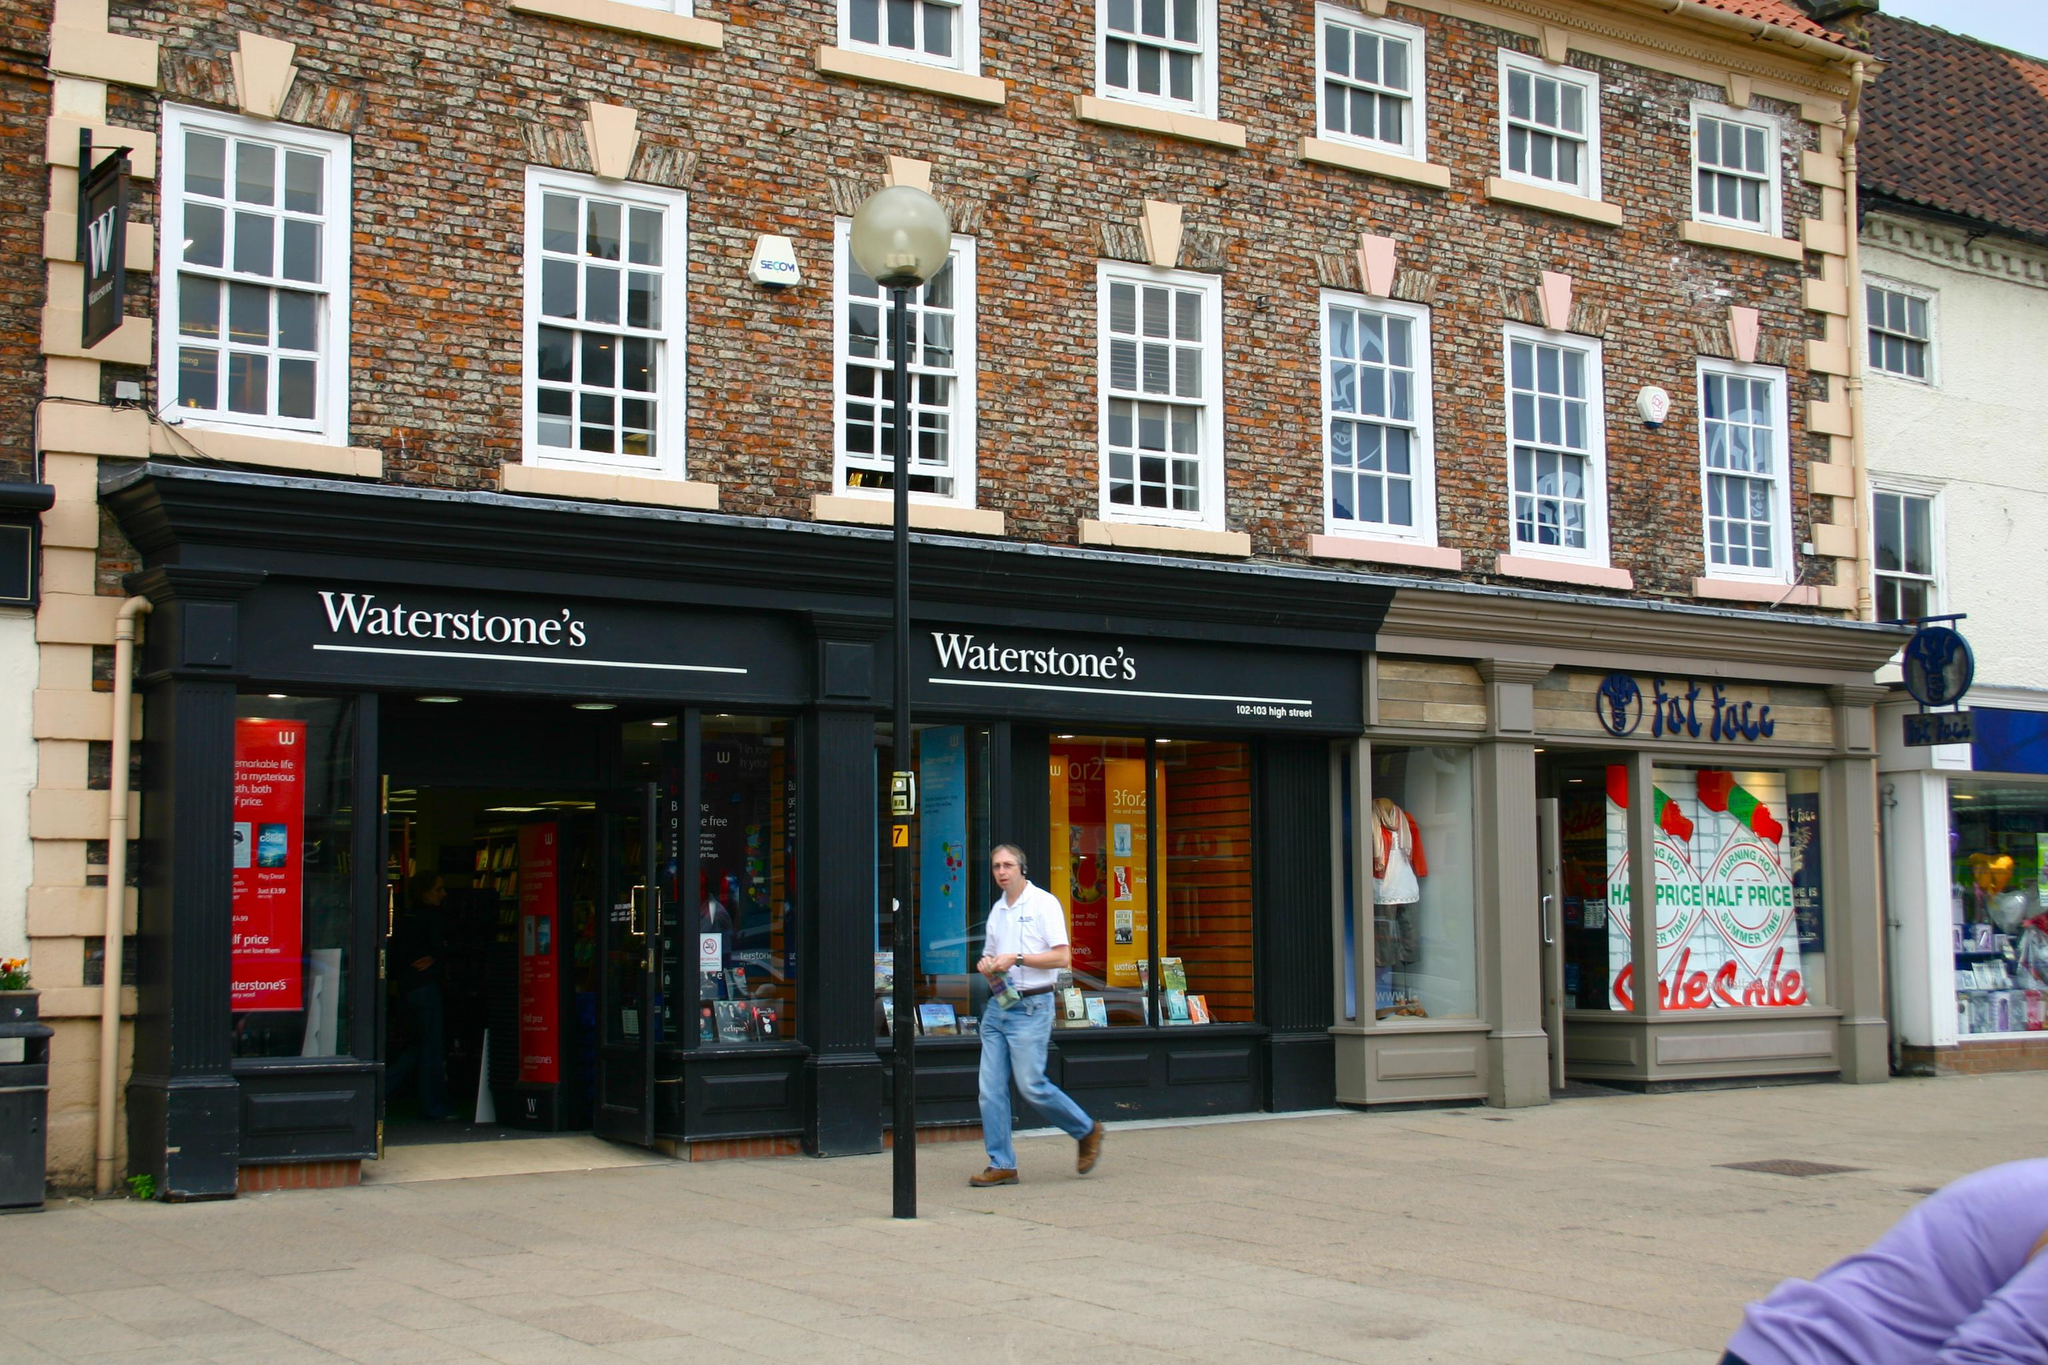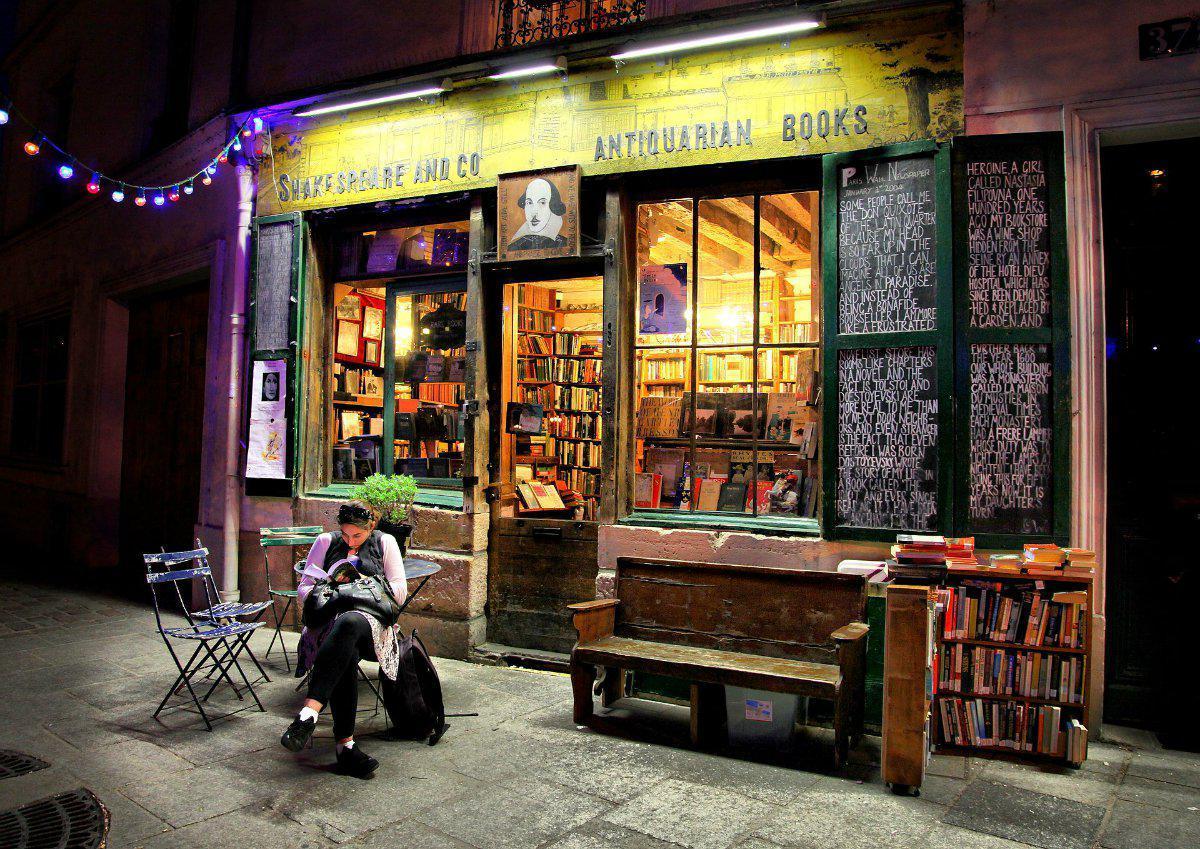The first image is the image on the left, the second image is the image on the right. Evaluate the accuracy of this statement regarding the images: "There are people sitting.". Is it true? Answer yes or no. Yes. The first image is the image on the left, the second image is the image on the right. Analyze the images presented: Is the assertion "Each image is of the sidewalk exterior of a bookstore, one with the front door standing open and one with the front door closed." valid? Answer yes or no. Yes. 